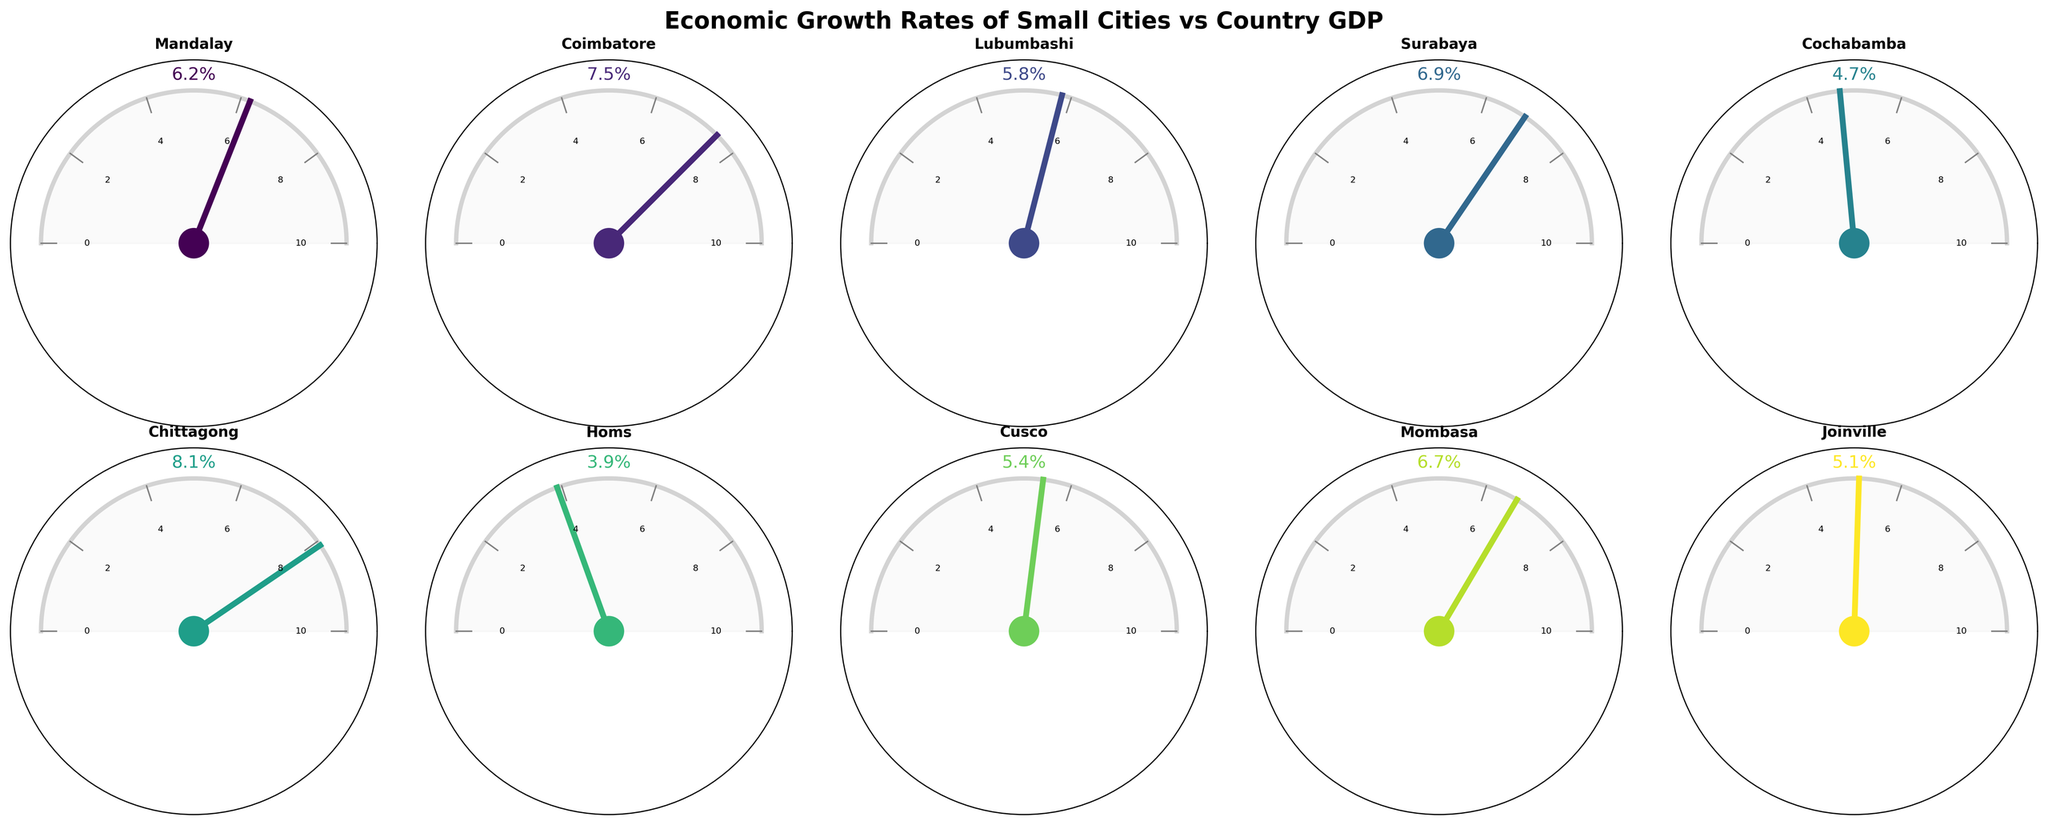What's the title of the figure? The title is displayed at the top of the figure, and it reads "Economic Growth Rates of Small Cities vs Country GDP".
Answer: Economic Growth Rates of Small Cities vs Country GDP How many cities are represented in the figure? By counting the number of subplots, each labeled with a city name, we can determine that there are 10 cities represented.
Answer: 10 Which city has the highest economic growth rate? By looking at the labels next to each gauge chart, it is clear that Chittagong has the highest economic growth rate at 8.1%.
Answer: Chittagong Which city has the lowest economic growth rate, and what is its rate? The lowest rate can be identified by looking at the smallest labeled percentage next to the gauge chart. Homs has the lowest economic growth rate at 3.9%.
Answer: Homs, 3.9% What is the gap between the economic growth rate of Mandalay and its country GDP growth rate? The economic growth rate for Mandalay is 6.2% and the country GDP growth rate is 4.8%. Subtracting the two gives 6.2% - 4.8% = 1.4%.
Answer: 1.4% Which city shows the widest gap between its economic growth rate and its country GDP growth rate? By calculating the difference for each city, Chittagong's economic growth rate (8.1%) and its country GDP growth rate (6.4%) results in the largest gap of 1.7%.
Answer: Chittagong What's the average economic growth rate of the listed cities? Summing up each city's economic growth rate (6.2 + 7.5 + 5.8 + 6.9 + 4.7 + 8.1 + 3.9 + 5.4 + 6.7 + 5.1 = 60.3) and dividing by the number of cities (10) gives 60.3 / 10 = 6.03%.
Answer: 6.03% How does the economic growth rate of Homs compare to the economic growth rate of the country it is in? Homs has an economic growth rate of 3.9%, while its country has a GDP growth rate of 2.8%. Homs' rate is 1.1 percentage points higher.
Answer: Higher by 1.1% Identify a city where the economic growth rate is close to the country’s GDP growth rate. Joinville's economic growth rate is 5.1%, and its country GDP growth rate is 3.8%. The difference is relatively small compared to others, with a gap of 1.3%.
Answer: Joinville If the economic growth rate percentage of Surabaya was 1.6% higher, what would the new rate be? Adding 1.6% to Surabaya's current rate (6.9%) gives a new rate of 6.9% + 1.6% = 8.5%.
Answer: 8.5% 